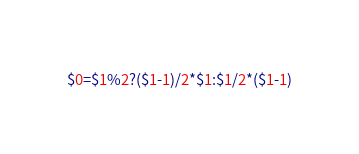Convert code to text. <code><loc_0><loc_0><loc_500><loc_500><_Awk_>$0=$1%2?($1-1)/2*$1:$1/2*($1-1)</code> 